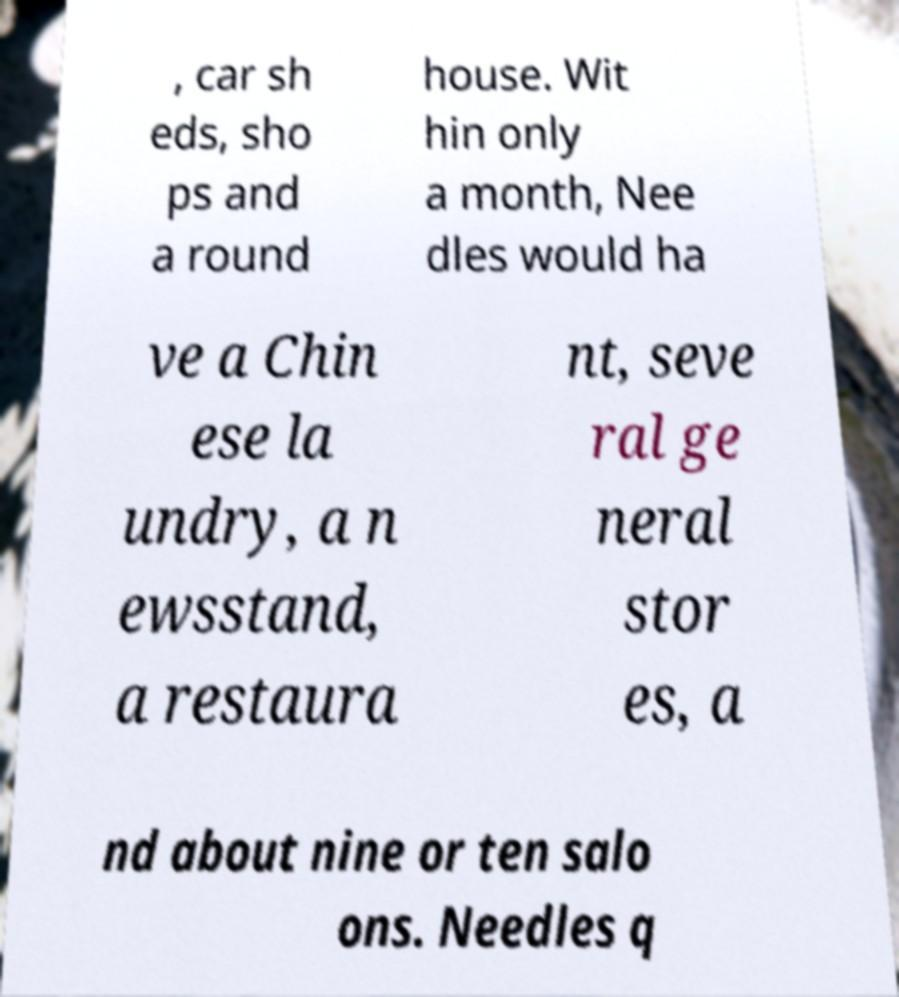Could you extract and type out the text from this image? , car sh eds, sho ps and a round house. Wit hin only a month, Nee dles would ha ve a Chin ese la undry, a n ewsstand, a restaura nt, seve ral ge neral stor es, a nd about nine or ten salo ons. Needles q 